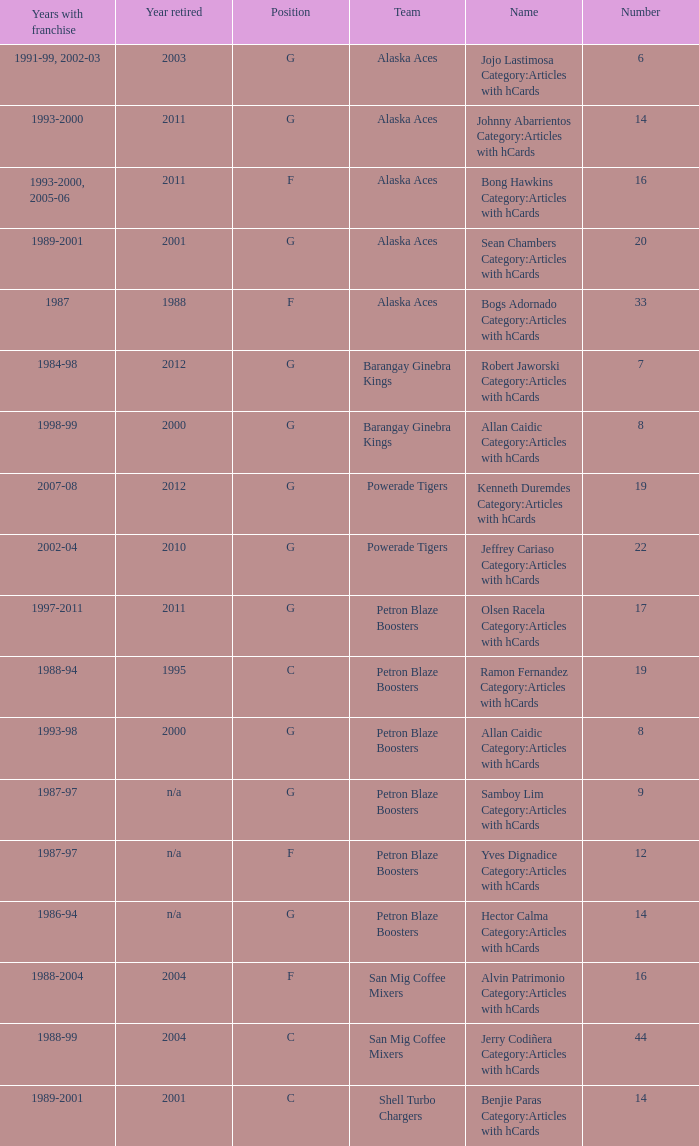How many years did the team in slot number 9 have a franchise? 1987-97. 